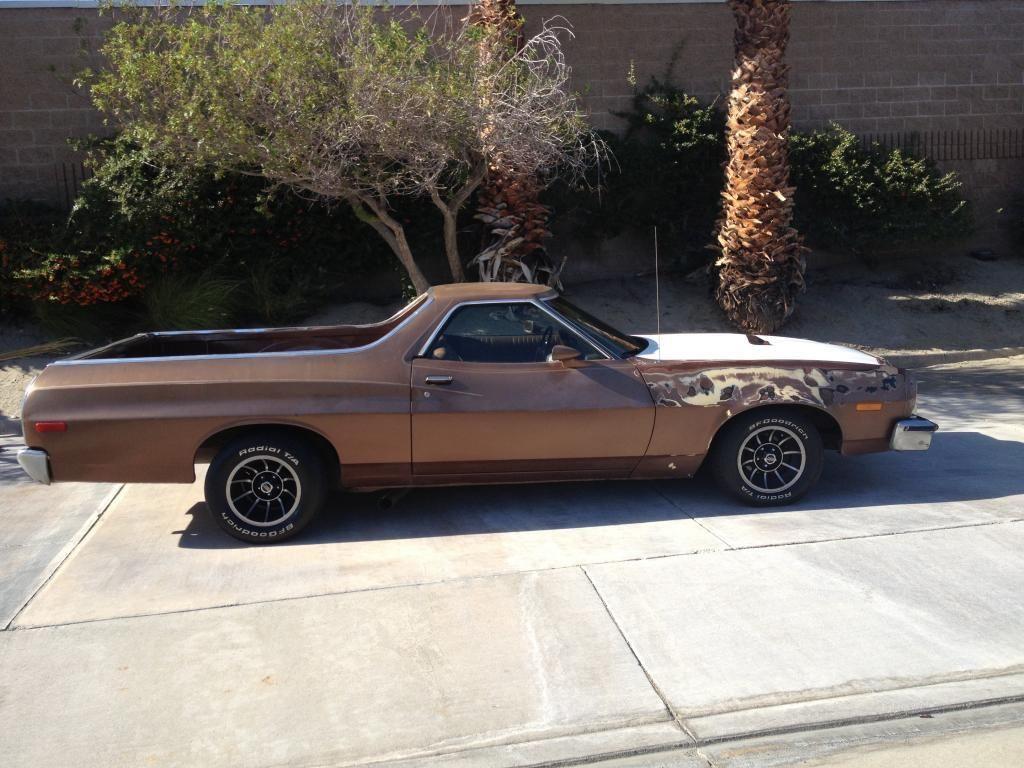Can you describe this image briefly? In this image I can see a vehicle in brown color, background I can see trees in green color and I can also see the wall. 